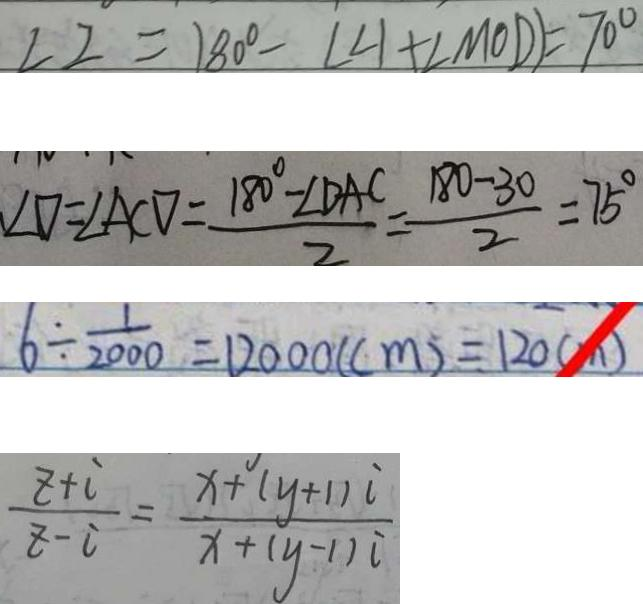Convert formula to latex. <formula><loc_0><loc_0><loc_500><loc_500>\angle 2 = 1 8 0 ^ { \circ } - ( \angle 1 + \angle M 0 D ) = 7 0 ^ { \circ } 
 \angle D = \angle A C D = \frac { 1 8 0 ^ { \circ } - \angle D A C } { 2 } = \frac { 1 8 0 - 3 0 } { 2 } = 7 5 ^ { \circ } 
 6 \div \frac { 1 } { 2 0 0 0 } = 1 2 0 0 0 ( c m ) = 1 2 0 ( m ) 
 \frac { z + i } { z - i } = \frac { x + ( y + 1 ) i } { x + ( y - 1 ) i }</formula> 